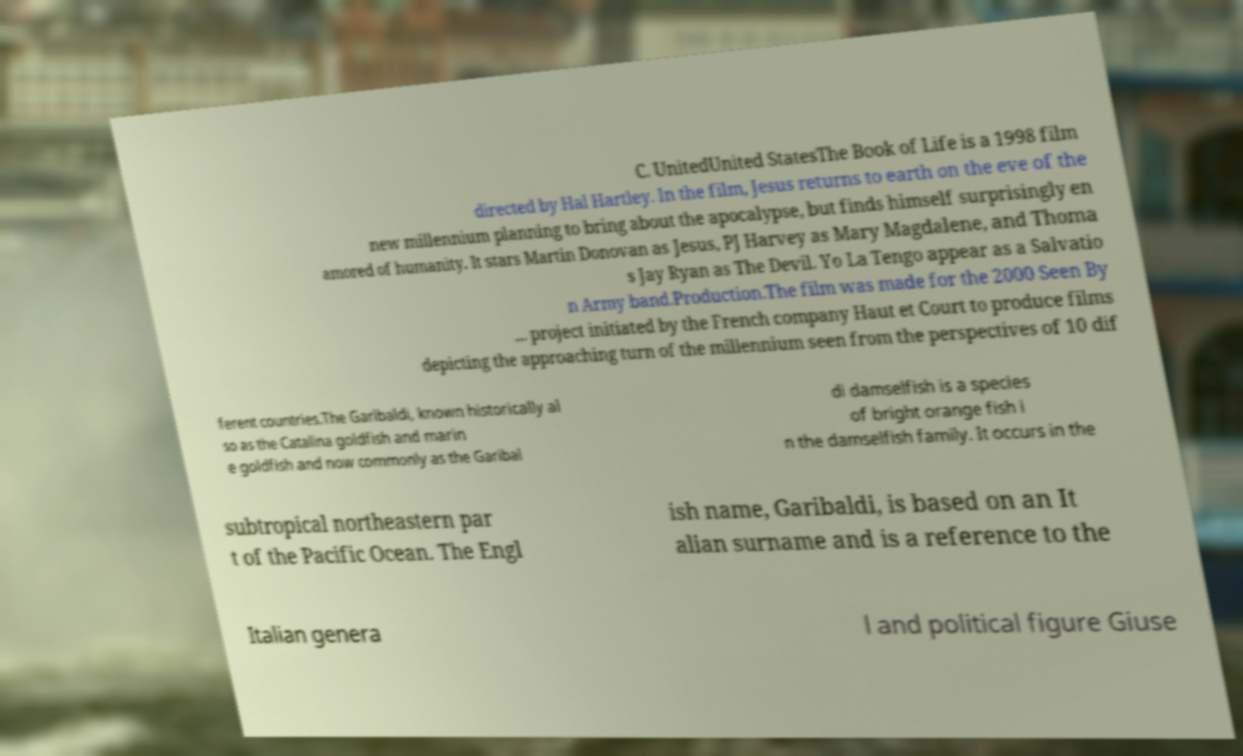Please identify and transcribe the text found in this image. C. UnitedUnited StatesThe Book of Life is a 1998 film directed by Hal Hartley. In the film, Jesus returns to earth on the eve of the new millennium planning to bring about the apocalypse, but finds himself surprisingly en amored of humanity. It stars Martin Donovan as Jesus, PJ Harvey as Mary Magdalene, and Thoma s Jay Ryan as The Devil. Yo La Tengo appear as a Salvatio n Army band.Production.The film was made for the 2000 Seen By ... project initiated by the French company Haut et Court to produce films depicting the approaching turn of the millennium seen from the perspectives of 10 dif ferent countries.The Garibaldi, known historically al so as the Catalina goldfish and marin e goldfish and now commonly as the Garibal di damselfish is a species of bright orange fish i n the damselfish family. It occurs in the subtropical northeastern par t of the Pacific Ocean. The Engl ish name, Garibaldi, is based on an It alian surname and is a reference to the Italian genera l and political figure Giuse 